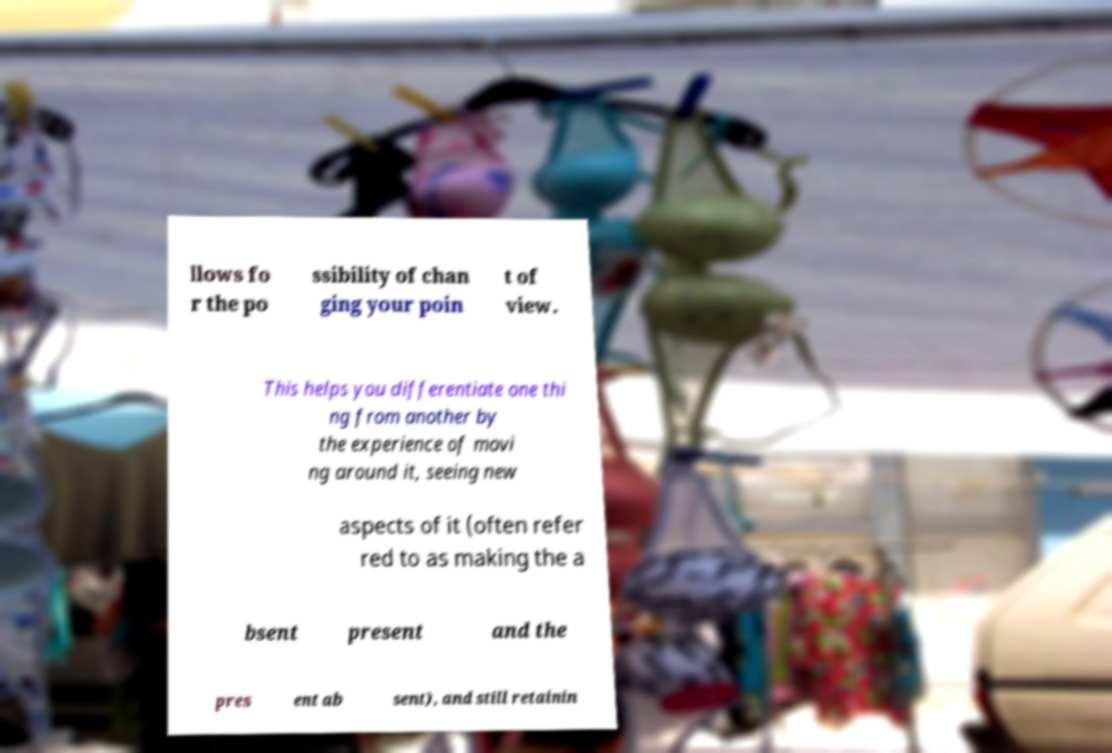Can you accurately transcribe the text from the provided image for me? llows fo r the po ssibility of chan ging your poin t of view. This helps you differentiate one thi ng from another by the experience of movi ng around it, seeing new aspects of it (often refer red to as making the a bsent present and the pres ent ab sent), and still retainin 